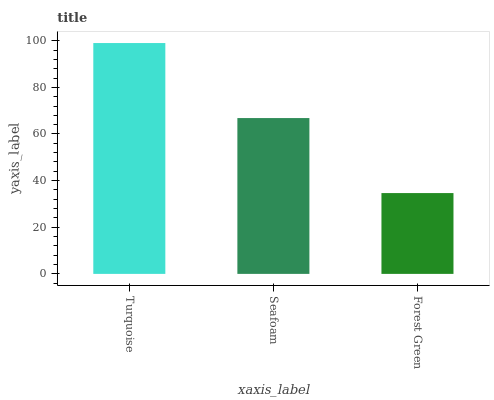Is Forest Green the minimum?
Answer yes or no. Yes. Is Turquoise the maximum?
Answer yes or no. Yes. Is Seafoam the minimum?
Answer yes or no. No. Is Seafoam the maximum?
Answer yes or no. No. Is Turquoise greater than Seafoam?
Answer yes or no. Yes. Is Seafoam less than Turquoise?
Answer yes or no. Yes. Is Seafoam greater than Turquoise?
Answer yes or no. No. Is Turquoise less than Seafoam?
Answer yes or no. No. Is Seafoam the high median?
Answer yes or no. Yes. Is Seafoam the low median?
Answer yes or no. Yes. Is Forest Green the high median?
Answer yes or no. No. Is Forest Green the low median?
Answer yes or no. No. 